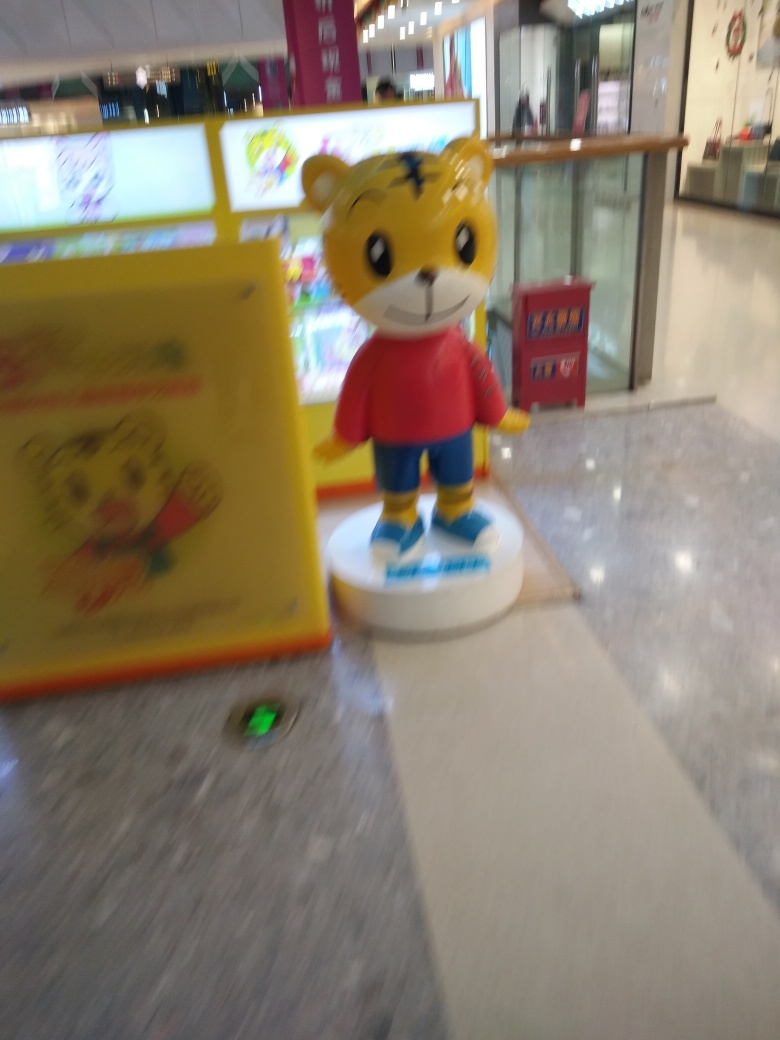Describe what the character looks like. The character appears to be a mascot or a figurine resembling an anthropomorphic animal, possibly a bear, dressed in human clothing - with a red top and blue bottom. The facial features are difficult to discern clearly due to the blur, but it seems to be designed to appear friendly and approachable. 